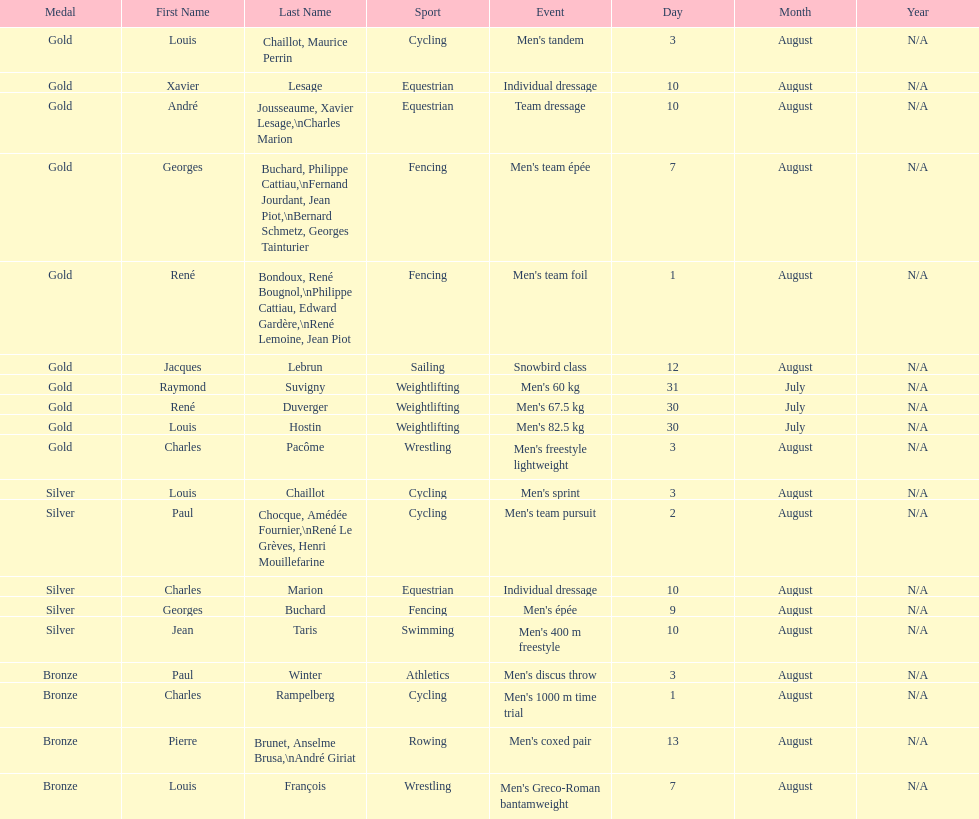Louis chaillot won a gold medal for cycling and a silver medal for what sport? Cycling. 